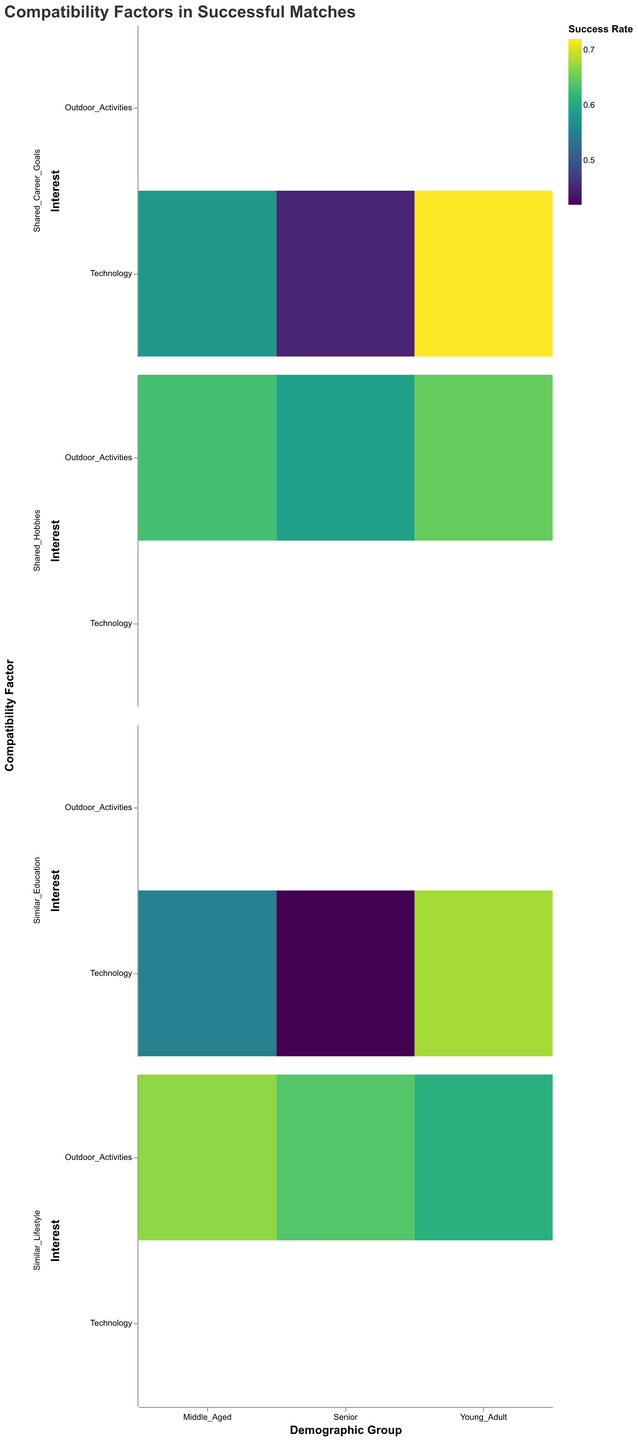What is the title of the plot? The title of the plot is usually displayed at the top and summarizes its purpose. In this plot, the title "Compatibility Factors in Successful Matches" indicates that the plot visualizes various compatibility factors related to successful matches across different demographic groups and interests.
Answer: Compatibility Factors in Successful Matches Which demographic group and interest combination has the highest success rate? To determine the highest success rate, examine all cells in the plot and find the cell with the deepest color shade (indicating the highest value). In this plot, identify the demographic and interest of the cell with the highest success rate.
Answer: Young_Adult, Technology, Shared_Career_Goals How many compatibility factors were analyzed for each demographic group? According to the plot, for each demographic group (Young_Adult, Middle_Aged, Senior), there are two interests (Technology and Outdoor_Activities) and two compatibility factors analyzed for each interest, leading to a total of four compatibility factors for each demographic group.
Answer: 4 Which demographic group and interest combination has the lowest success rate? Looking for the lightest colored cell in the plot will help identify the combination with the lowest success rate. In this plot, the lowest success rate is found in the Senior demographic with Technology interest and Similar Education compatibility factor.
Answer: Senior, Technology, Similar_Education What is the average success rate for Middle Aged individuals interested in Outdoor Activities? To find the average success rate for Middle Aged individuals interested in Outdoor Activities, sum the success rates of the Shared Hobbies and Similar Lifestyle compatibility factors and then divide by the number of factors (2). The success rates are 0.63 and 0.67. So, (0.63 + 0.67) / 2 = 0.65.
Answer: 0.65 Which compatibility factor generally shows higher success rates across all demographic groups and interests? Compare the success rates of each compatibility factor across different demographics and interests. Shared Career Goals and Shared Hobbies generally show higher success rates, but Shared Career Goals have higher success rates for Technology interest, so it is the compatibility factor with generally higher success rates.
Answer: Shared_Career_Goals Is there a trend in success rates associated with Similar Education compatibility factor across different demographic groups? Analyze the success rates associated with Similar Education for each demographic group. For Young_Adults, the rate is 0.68; for Middle_Aged, it's 0.55; and for Seniors, it's 0.42. This shows a decreasing trend in success rates from younger to older demographic groups.
Answer: Decreasing trend Which demographic group has the highest average success rate overall, and what is that average? Calculate the average success rate for each demographic group across all compatibility factors and interests. For Young_Adults: (0.72+0.68+0.65+0.61)/4 = 0.665; Middle_Aged: (0.58+0.55+0.63+0.67)/4 = 0.6075; Seniors: (0.45+0.42+0.59+0.64)/4 = 0.525. Young Adults have the highest average success rate.
Answer: Young_Adult, 0.665 How do the success rates of Shared Hobbies compare between Young Adults and Seniors? Look at the success rates of the Shared Hobbies compatibility factor for Young Adults and Seniors. For Young Adults, the success rate is 0.65; for Seniors, it's 0.59. Compare these values directly.
Answer: 0.65 vs 0.59 What is the difference in success rates between the two interests for Middle Aged individuals with Similar Education? Compare the success rates of Similar Education under different interests for Middle Aged individuals. For Technology, it's 0.55; for Outdoor Activities, data isn't specified directly, so only consider Technology versus the combined interests for overall. Subtract the two values: 0.55 - 0.67 = -0.12
Answer: -0.12 